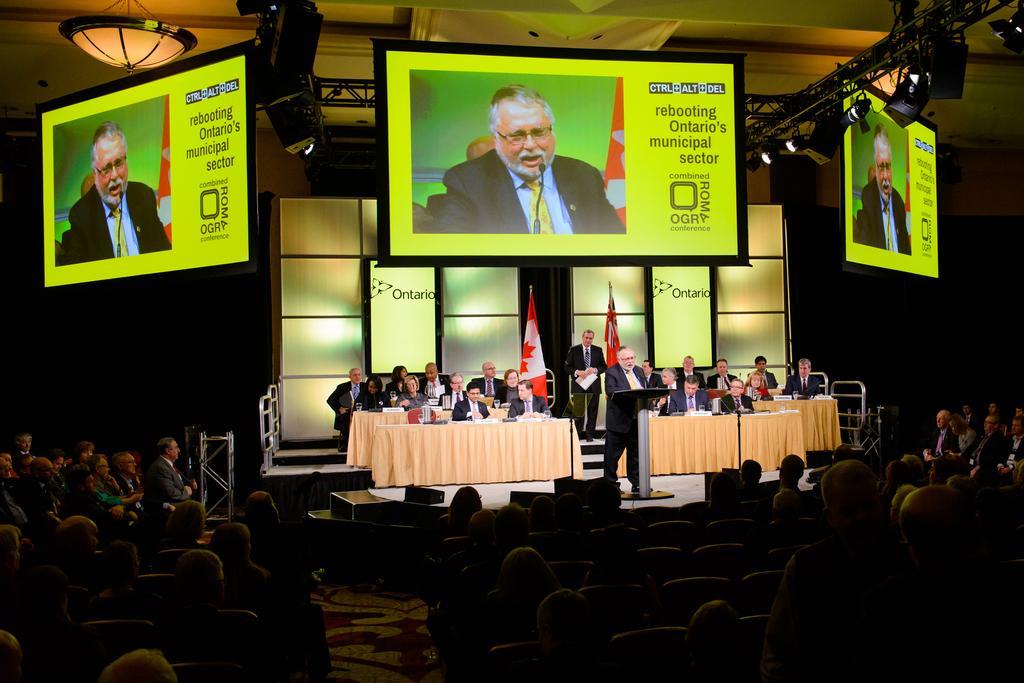Can you describe this image briefly? In the middle of this image I can see few people are sitting on the chairs. In front of these people I can see few tables which are covered with the clothes. Two persons are standing. This is a stage at the back of these people I can see two flags and also there is a board. At the bottom of the image I can see many people are sitting in the dark. At the top I can see three screens and lights which are attached to the metal rods. 